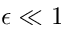<formula> <loc_0><loc_0><loc_500><loc_500>\epsilon \ll 1</formula> 